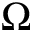Convert formula to latex. <formula><loc_0><loc_0><loc_500><loc_500>\Omega</formula> 